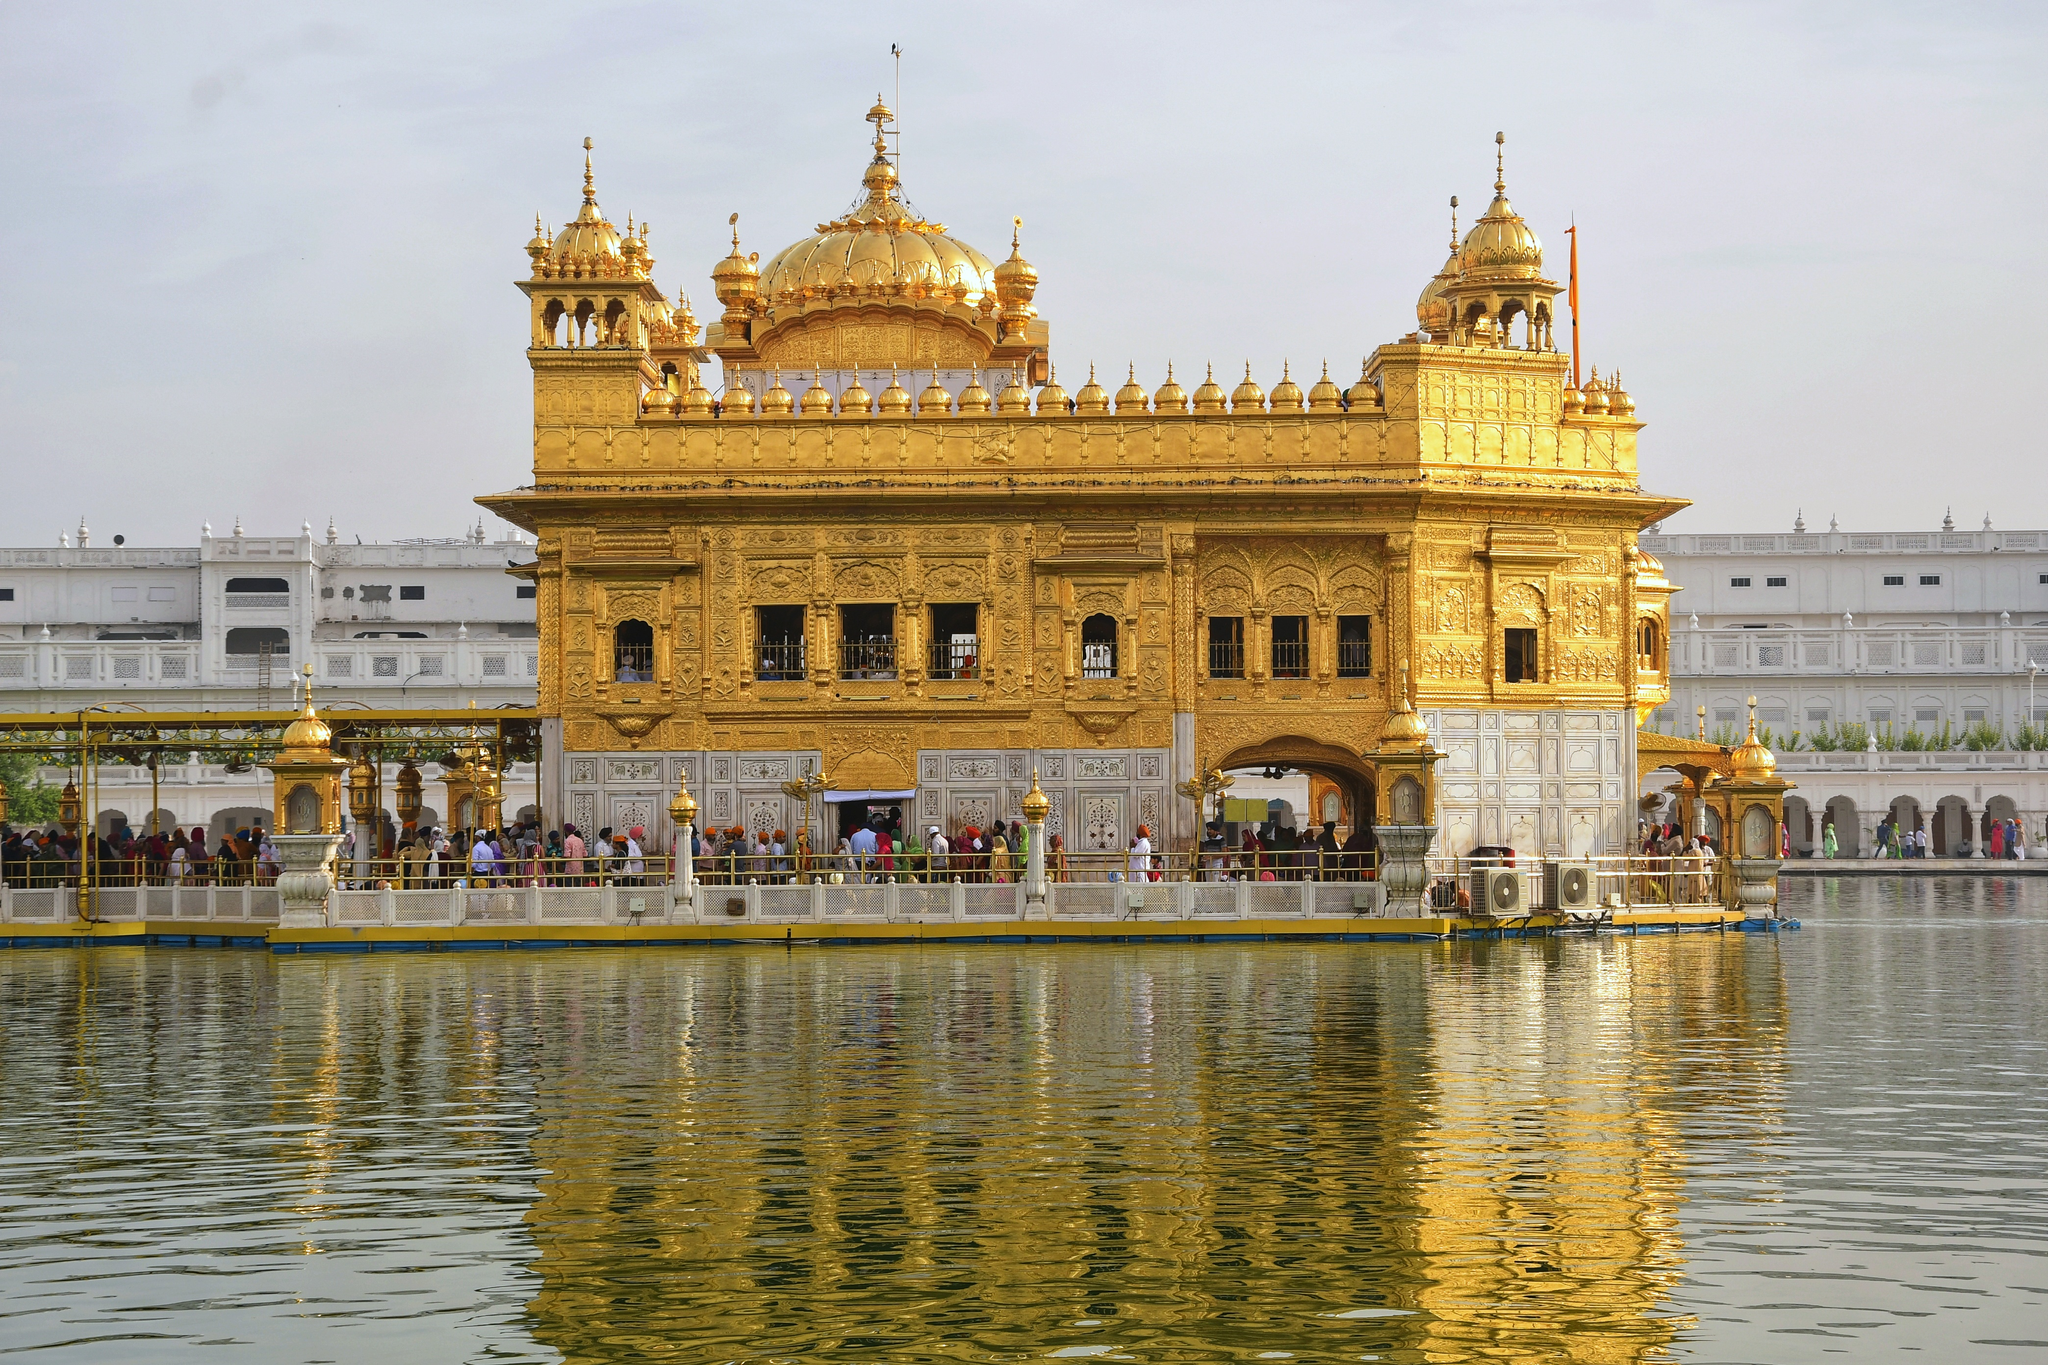What are the cultural and religious importance of this temple? The Golden Temple, or Harmandir Sahib, holds immense cultural and religious significance for the Sikh community worldwide. It epitomizes inclusivity, a core Sikh principle, as it has four entrances from all four directions, symbolizing the openness of Sikhs towards all people and religions. Historically, it not only serves as a place of worship but also a symbol of brotherhood and equality. The temple's central scripture, Guru Granth Sahib, is read continuously, and the 'langar', a free community kitchen, serves meals to all visitors regardless of religion, caste, or creed, emphasizing service and communal unity. This practice of 'seva' (selfless service) and devotion uplifts the spiritual experience, making it a vital place for nourishment of both body and soul. 